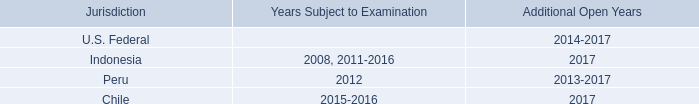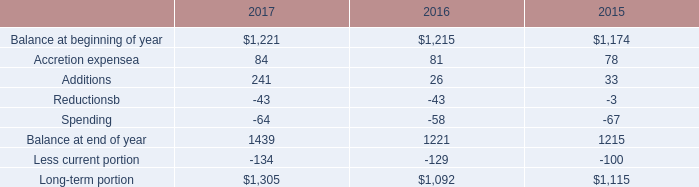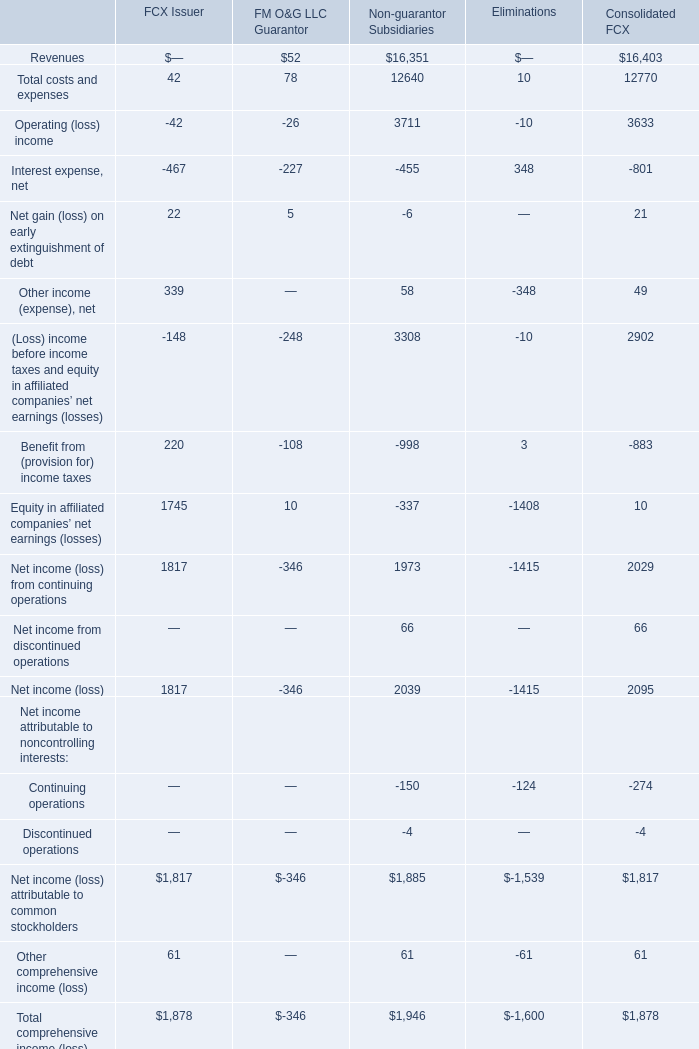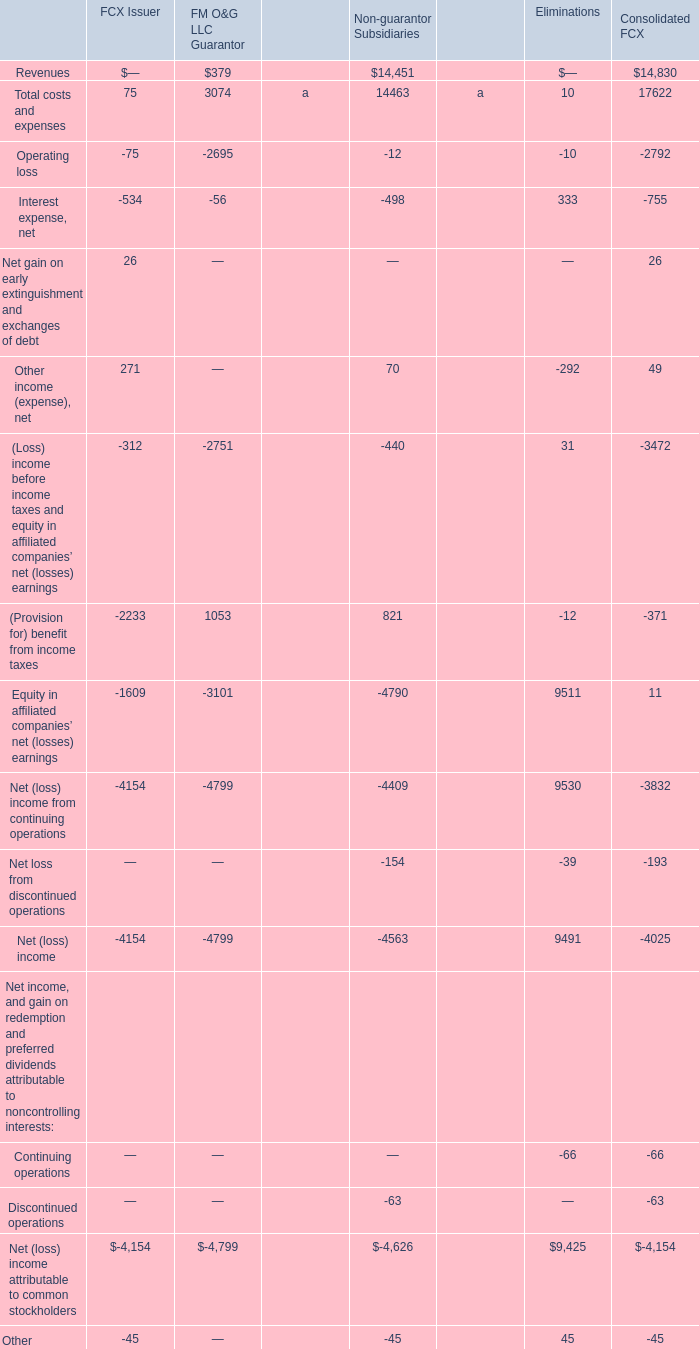What will Total comprehensive income (loss) reach in next year if it continues to grow at its current rate? 
Computations: ((((1878 - 1600) / 1878) * 1878) + 1878)
Answer: 2156.0. 